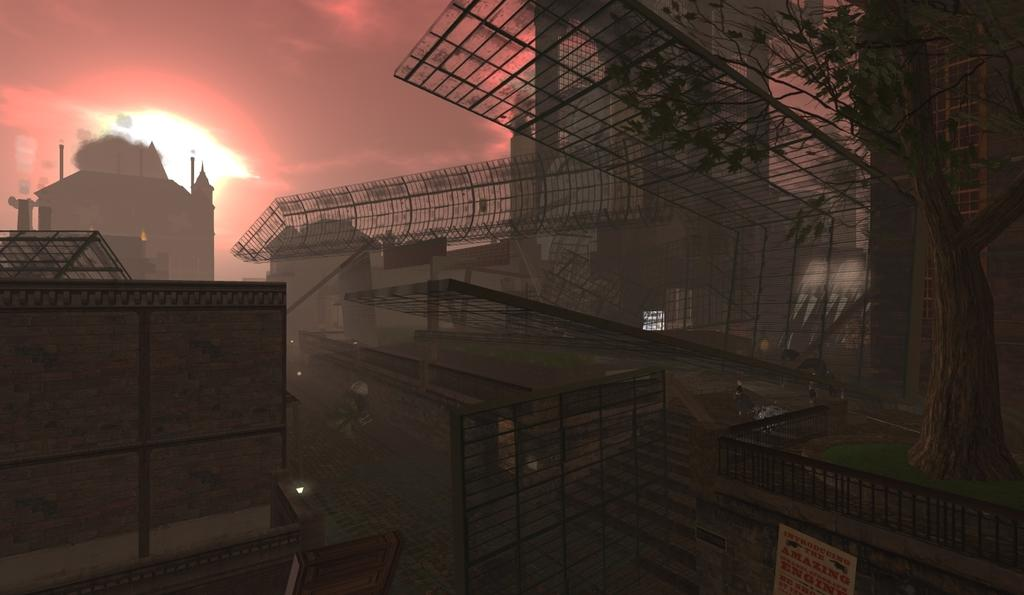What type of structures are visible in the image? There are buildings in the image. What can be seen near the buildings? There is a railing in the image. How would you describe the sky in the background of the image? The background of the image includes an orange and gray sky. How many visitors are present near the hose in the image? There is no hose or visitors present in the image. Which direction is the image facing, north or south? The image does not indicate a specific direction, such as north or south. 